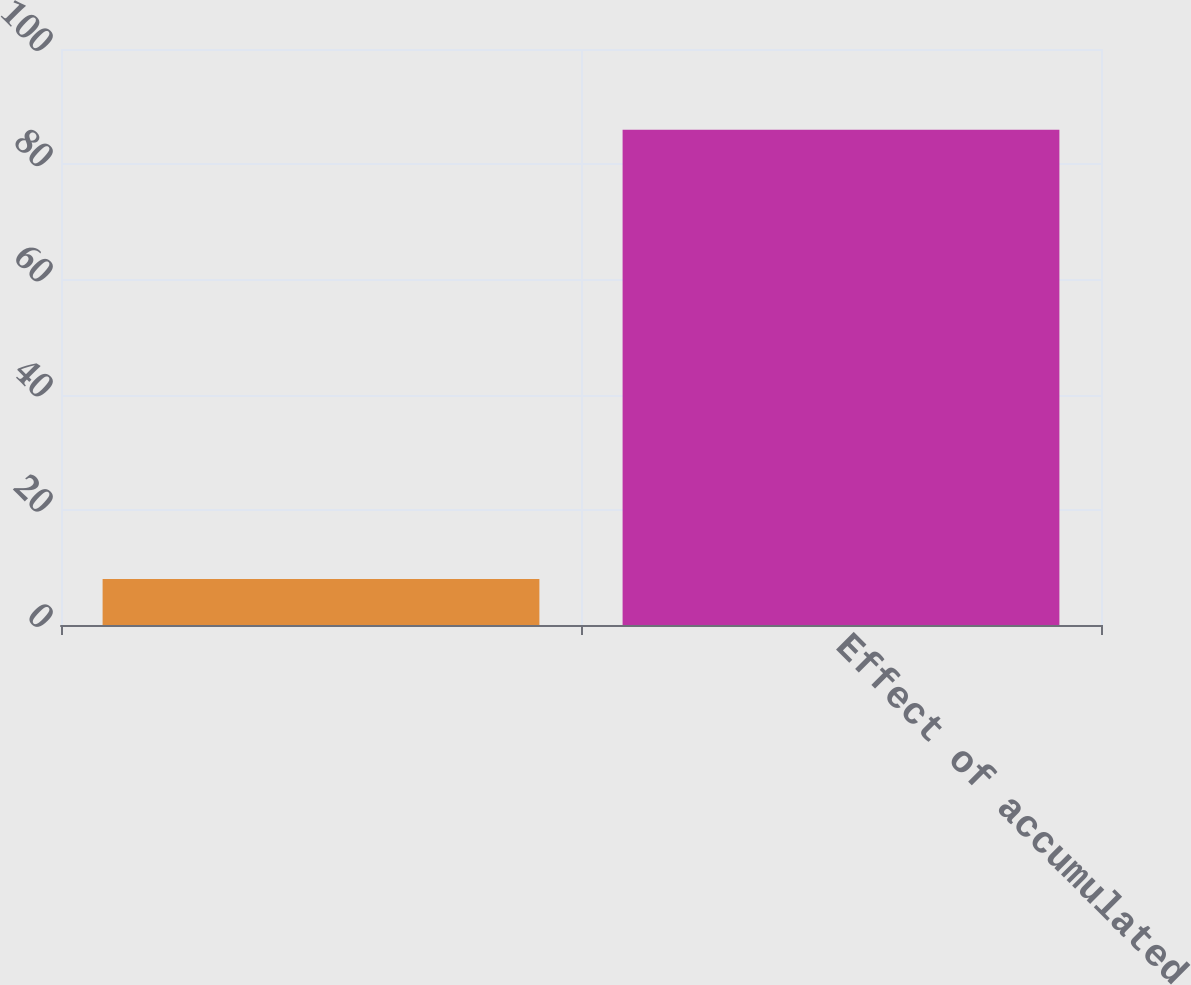<chart> <loc_0><loc_0><loc_500><loc_500><bar_chart><ecel><fcel>Effect of accumulated<nl><fcel>8<fcel>86<nl></chart> 